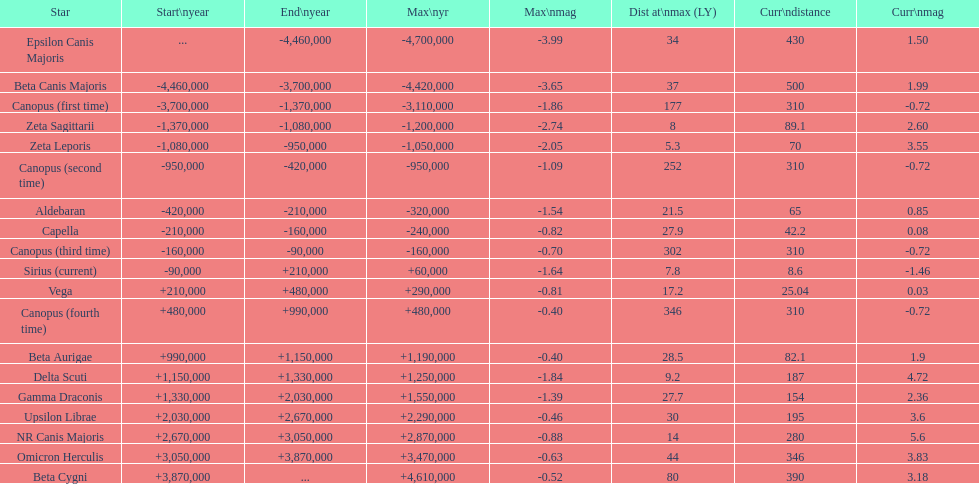How many stars have a distance at maximum of 30 light years or higher? 9. 